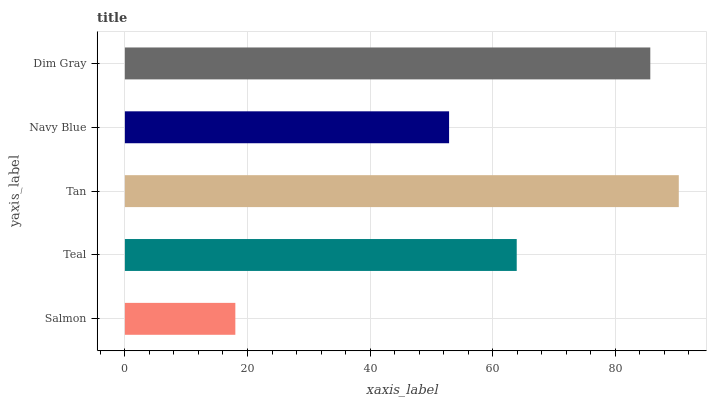Is Salmon the minimum?
Answer yes or no. Yes. Is Tan the maximum?
Answer yes or no. Yes. Is Teal the minimum?
Answer yes or no. No. Is Teal the maximum?
Answer yes or no. No. Is Teal greater than Salmon?
Answer yes or no. Yes. Is Salmon less than Teal?
Answer yes or no. Yes. Is Salmon greater than Teal?
Answer yes or no. No. Is Teal less than Salmon?
Answer yes or no. No. Is Teal the high median?
Answer yes or no. Yes. Is Teal the low median?
Answer yes or no. Yes. Is Salmon the high median?
Answer yes or no. No. Is Salmon the low median?
Answer yes or no. No. 